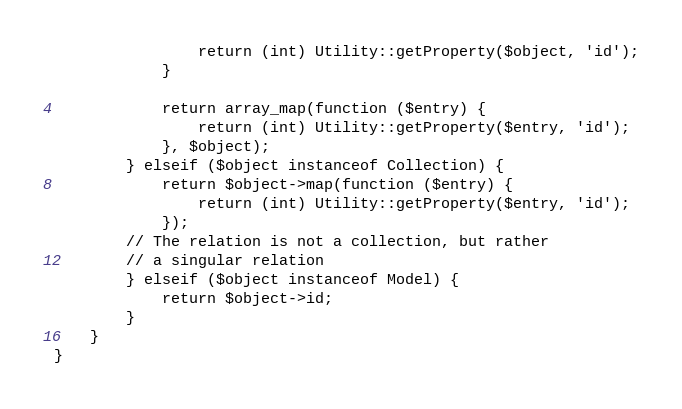Convert code to text. <code><loc_0><loc_0><loc_500><loc_500><_PHP_>                return (int) Utility::getProperty($object, 'id');
            }

            return array_map(function ($entry) {
                return (int) Utility::getProperty($entry, 'id');
            }, $object);
        } elseif ($object instanceof Collection) {
            return $object->map(function ($entry) {
                return (int) Utility::getProperty($entry, 'id');
            });
        // The relation is not a collection, but rather
        // a singular relation
        } elseif ($object instanceof Model) {
            return $object->id;
        }
    }
}
</code> 